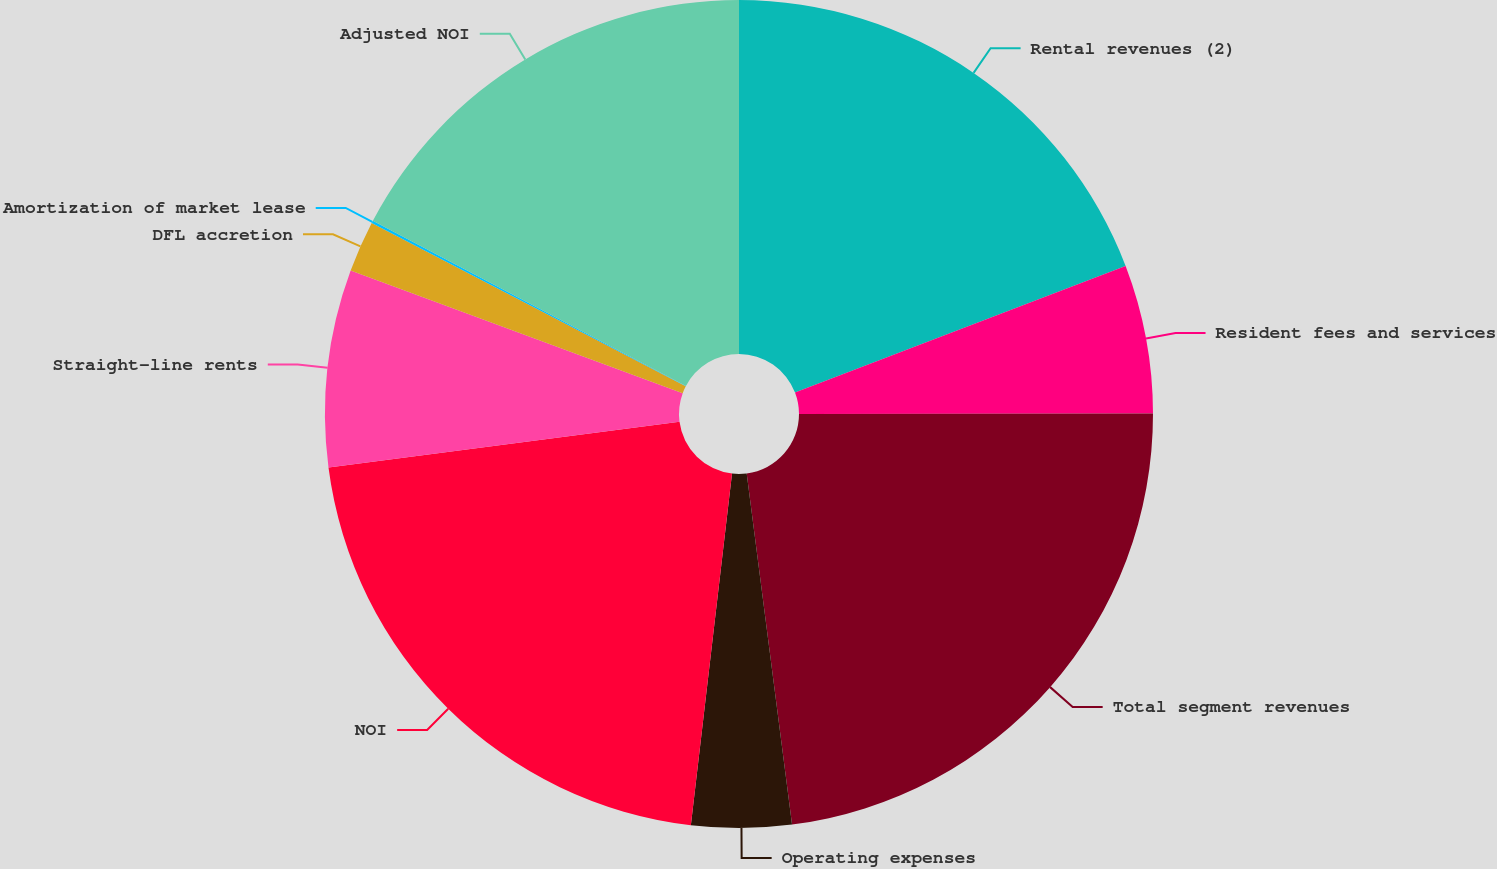<chart> <loc_0><loc_0><loc_500><loc_500><pie_chart><fcel>Rental revenues (2)<fcel>Resident fees and services<fcel>Total segment revenues<fcel>Operating expenses<fcel>NOI<fcel>Straight-line rents<fcel>DFL accretion<fcel>Amortization of market lease<fcel>Adjusted NOI<nl><fcel>19.18%<fcel>5.8%<fcel>22.98%<fcel>3.9%<fcel>21.08%<fcel>7.7%<fcel>2.0%<fcel>0.1%<fcel>17.27%<nl></chart> 